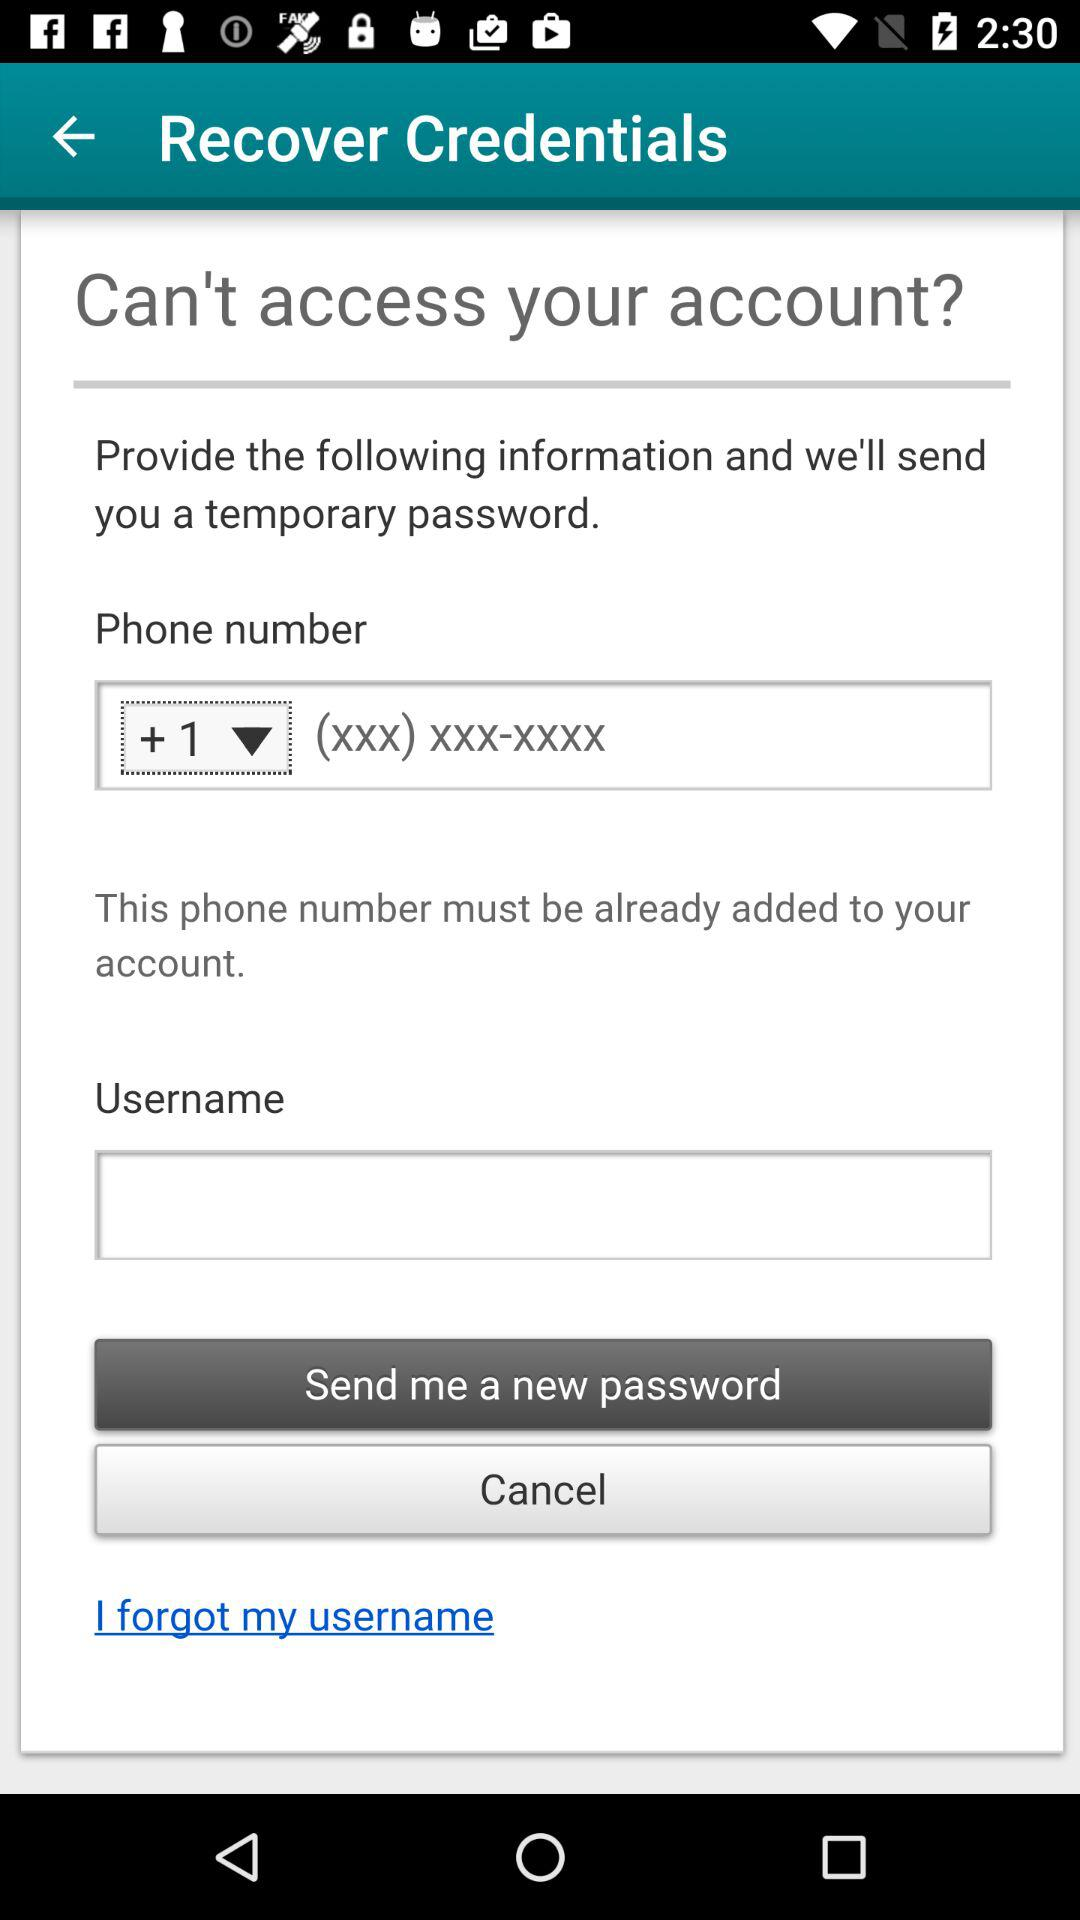What is the country code? The country code is +1. 